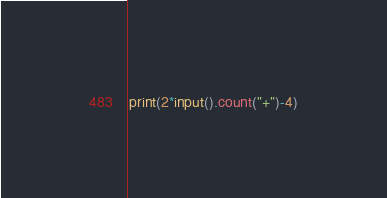<code> <loc_0><loc_0><loc_500><loc_500><_Python_>print(2*input().count("+")-4)</code> 